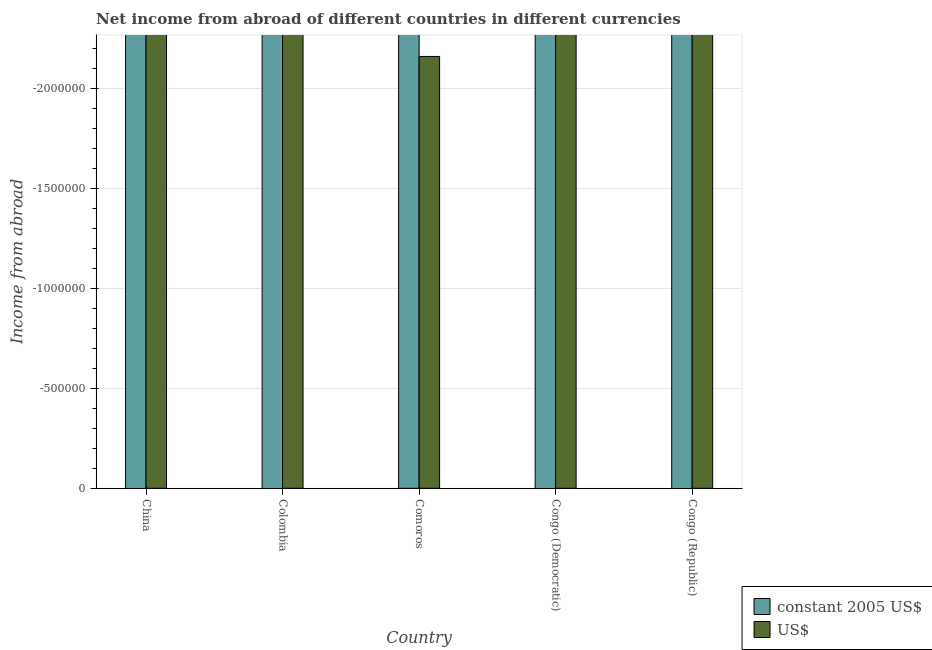How many different coloured bars are there?
Make the answer very short. 0. Are the number of bars per tick equal to the number of legend labels?
Your response must be concise. No. How many bars are there on the 3rd tick from the right?
Your answer should be compact. 0. What is the label of the 4th group of bars from the left?
Offer a very short reply. Congo (Democratic). In how many cases, is the number of bars for a given country not equal to the number of legend labels?
Your answer should be compact. 5. What is the income from abroad in constant 2005 us$ in China?
Your answer should be compact. 0. What is the difference between the income from abroad in constant 2005 us$ in Congo (Democratic) and the income from abroad in us$ in Colombia?
Offer a very short reply. 0. In how many countries, is the income from abroad in us$ greater than -1100000 units?
Ensure brevity in your answer.  0. How many bars are there?
Provide a short and direct response. 0. How many countries are there in the graph?
Provide a short and direct response. 5. What is the difference between two consecutive major ticks on the Y-axis?
Your answer should be compact. 5.00e+05. How many legend labels are there?
Your answer should be compact. 2. How are the legend labels stacked?
Give a very brief answer. Vertical. What is the title of the graph?
Make the answer very short. Net income from abroad of different countries in different currencies. Does "Domestic liabilities" appear as one of the legend labels in the graph?
Offer a very short reply. No. What is the label or title of the Y-axis?
Keep it short and to the point. Income from abroad. What is the Income from abroad in US$ in China?
Your answer should be very brief. 0. What is the Income from abroad of constant 2005 US$ in Comoros?
Your response must be concise. 0. What is the Income from abroad in US$ in Comoros?
Provide a short and direct response. 0. What is the Income from abroad of constant 2005 US$ in Congo (Democratic)?
Give a very brief answer. 0. What is the Income from abroad in US$ in Congo (Democratic)?
Keep it short and to the point. 0. What is the Income from abroad of US$ in Congo (Republic)?
Your response must be concise. 0. What is the total Income from abroad of constant 2005 US$ in the graph?
Make the answer very short. 0. What is the total Income from abroad of US$ in the graph?
Ensure brevity in your answer.  0. 